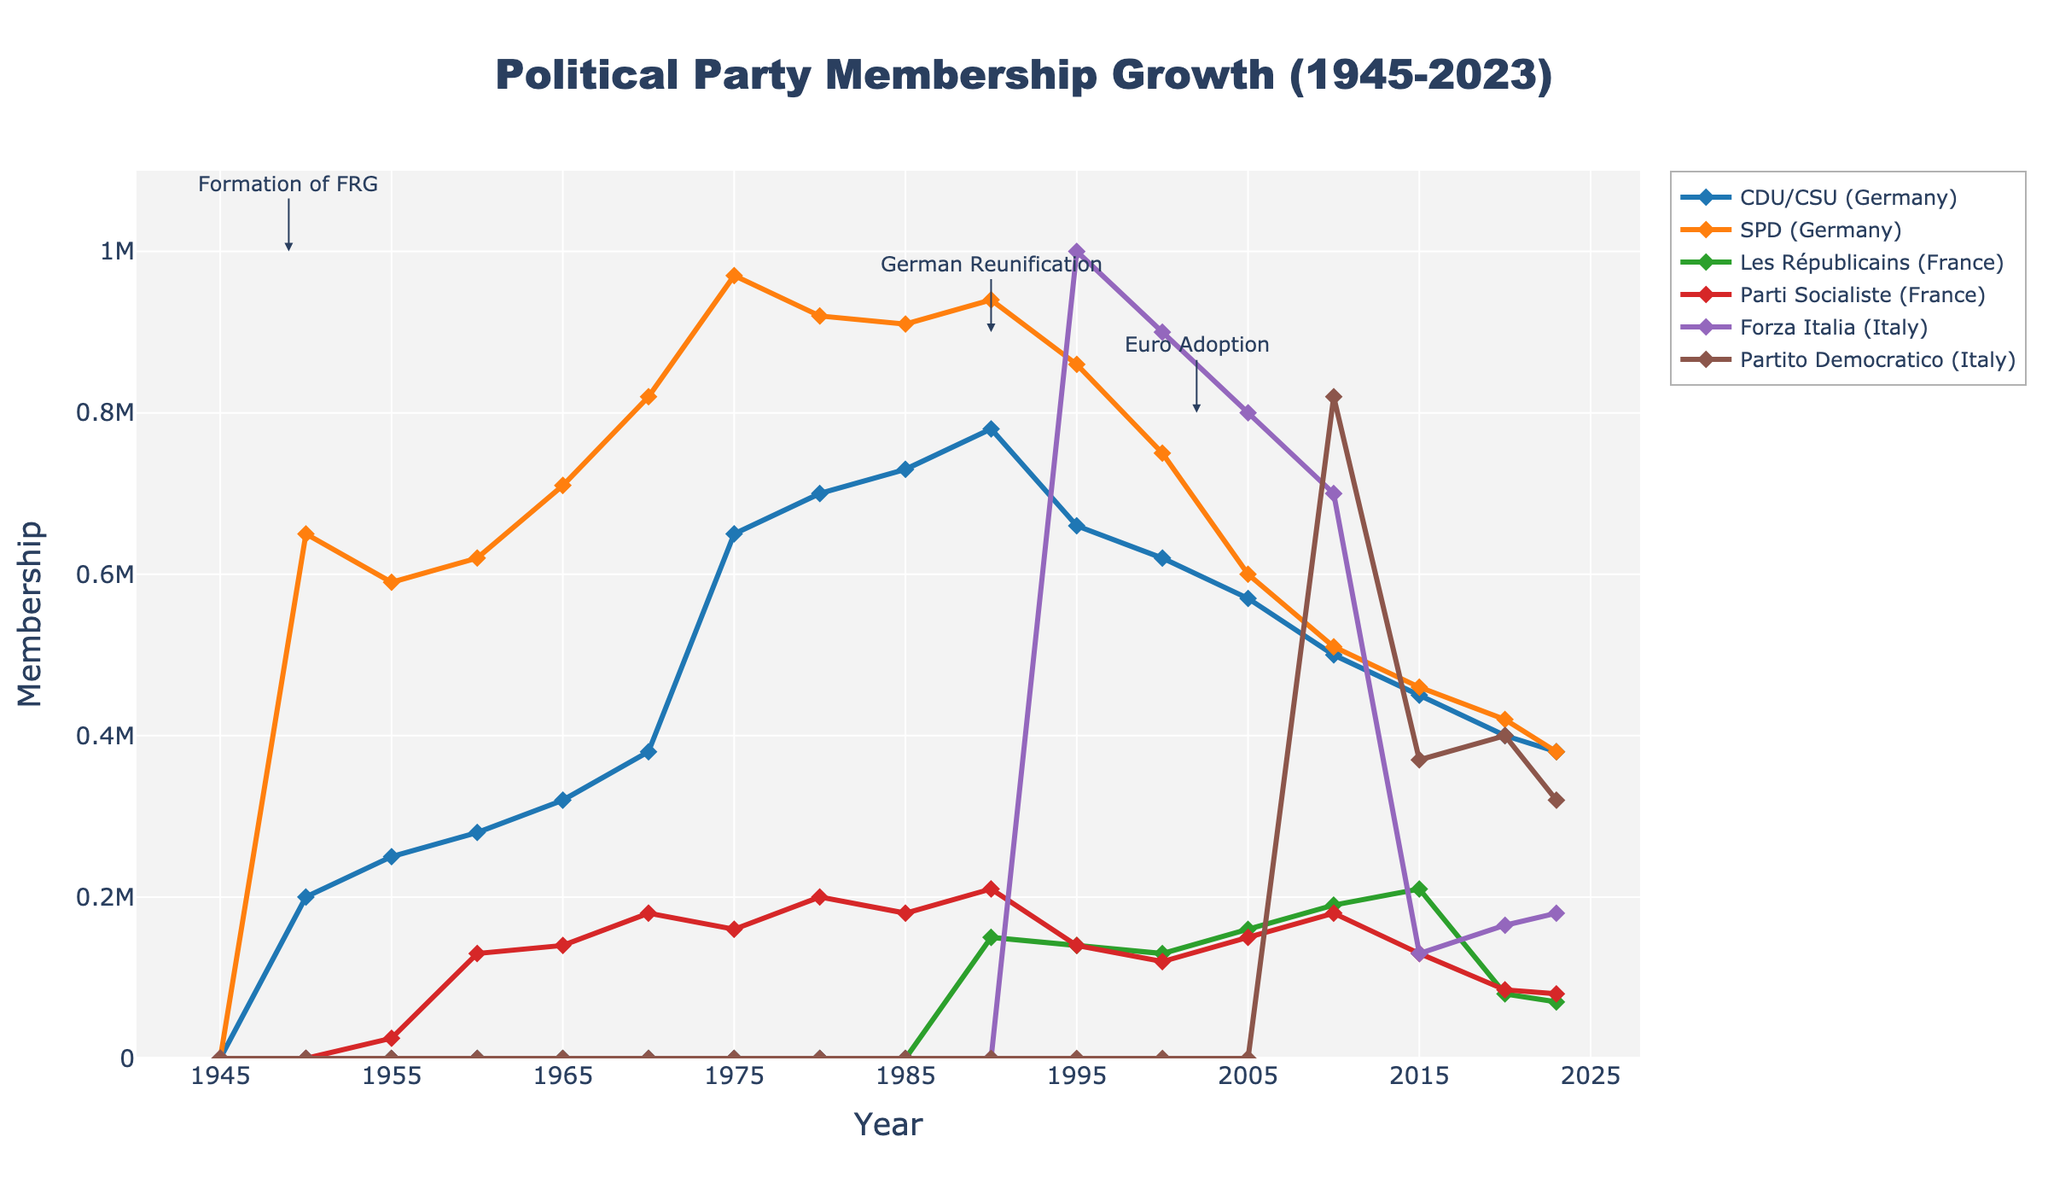Which political party had the highest membership in 1975? Look at the year 1975 on the x-axis and identify the highest point among the lines. The SPD (Germany) has the highest membership at this point.
Answer: SPD (Germany) How does the membership of CDU/CSU (Germany) in 2023 compare with its membership in 1950? Locate the membership for CDU/CSU (Germany) at the years 1950 and 2023 and compare the values. In 1950, the membership was 200,000, and in 2023, it is 380,000, showing an increase.
Answer: Higher in 2023 Which party shows the most significant decline in membership from 1990 to 2023? Examine the membership values for all parties in 1990 and 2023, and calculate the change. The SPD (Germany) drops from 940,000 in 1990 to 380,000 in 2023, which is the greatest decline.
Answer: SPD (Germany) What is the sum of memberships of CDU/CSU (Germany) and Forza Italia (Italy) in 1995? Add the membership of CDU/CSU (Germany) and Forza Italia (Italy) for the year 1995: 660,000 + 1,000,000.
Answer: 1,660,000 Which two parties had the closest memberships in 2020? Compare the memberships of all parties in 2020 to identify the closest values. Les Républicains (France) with 80,000 and Parti Socialiste (France) with 85,000 are the closest.
Answer: Les Républicains (France) and Parti Socialiste (France) Between 2005 and 2010, which political party in France showed membership growth while the other declined? Compare the membership changes for Les Républicains (France) and Parti Socialiste (France) between 2005 and 2010. Les Républicains (France) grew from 160,000 to 190,000, while Parti Socialiste (France) grew from 150,000 to 180,000. However, both grew, so find other comparisons.
Answer: Les Républicains (France) grew more What is the difference in membership between SPD (Germany) and Partito Democratico (Italy) in 2015? Subtract the membership of Partito Democratico (Italy) from SPD (Germany) for the year 2015: 460,000 - 370,000.
Answer: 90,000 Which party had the lowest membership in 1980 and what was it? Identify the lowest point on the chart for the year 1980. The lowest membership is for Les Républicains (France) which was 0 at that point.
Answer: Les Républicains (France), 0 How did the membership of Forza Italia (Italy) change from 1995 to 2020, and by how much? Calculate the difference in membership from 1995 to 2020 for Forza Italia (Italy): 1,000,000 (1995) - 165,000 (2020).
Answer: Decreased by 835,000 